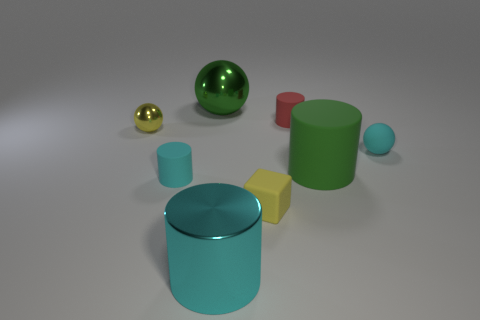Subtract all purple cylinders. Subtract all brown cubes. How many cylinders are left? 4 Add 1 tiny cyan matte cylinders. How many objects exist? 9 Subtract all cubes. How many objects are left? 7 Add 3 large yellow metallic blocks. How many large yellow metallic blocks exist? 3 Subtract 0 blue cylinders. How many objects are left? 8 Subtract all big cyan cubes. Subtract all large matte things. How many objects are left? 7 Add 5 cyan metal things. How many cyan metal things are left? 6 